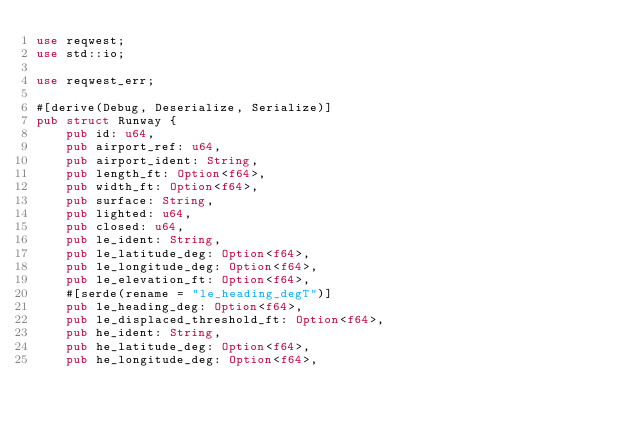<code> <loc_0><loc_0><loc_500><loc_500><_Rust_>use reqwest;
use std::io;

use reqwest_err;

#[derive(Debug, Deserialize, Serialize)]
pub struct Runway {
    pub id: u64,
    pub airport_ref: u64,
    pub airport_ident: String,
    pub length_ft: Option<f64>,
    pub width_ft: Option<f64>,
    pub surface: String,
    pub lighted: u64,
    pub closed: u64,
    pub le_ident: String,
    pub le_latitude_deg: Option<f64>,
    pub le_longitude_deg: Option<f64>,
    pub le_elevation_ft: Option<f64>,
    #[serde(rename = "le_heading_degT")]
    pub le_heading_deg: Option<f64>,
    pub le_displaced_threshold_ft: Option<f64>,
    pub he_ident: String,
    pub he_latitude_deg: Option<f64>,
    pub he_longitude_deg: Option<f64>,</code> 